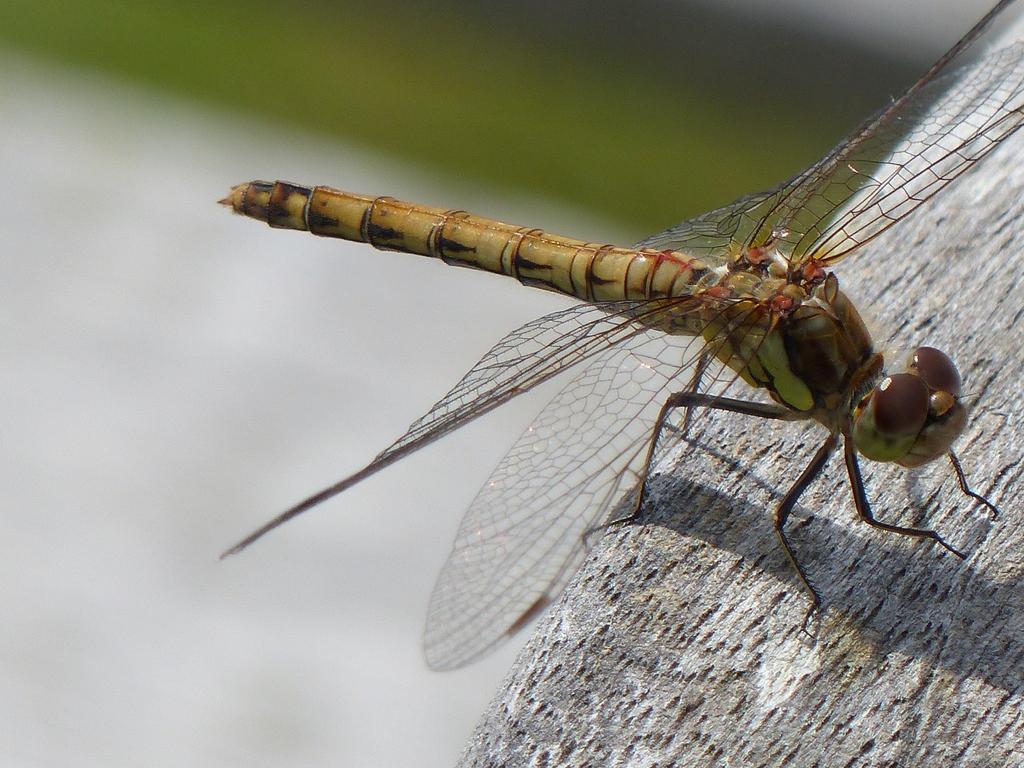Describe this image in one or two sentences. This image consists of a dragonfly sitting on a tree. The background is blurred. To the right, there is a tree. 